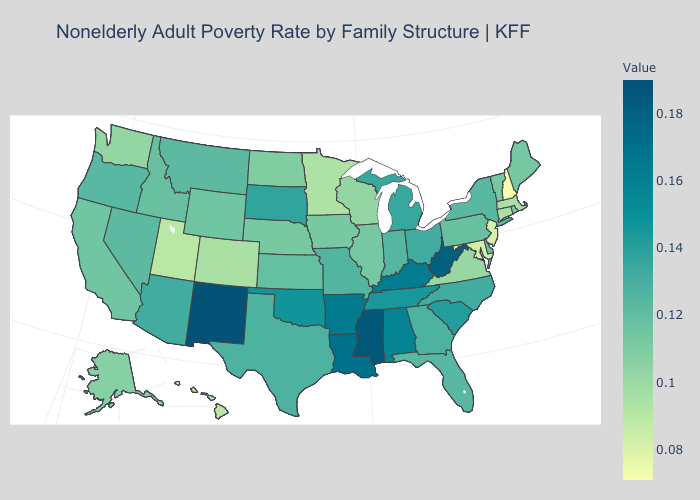Which states have the highest value in the USA?
Be succinct. New Mexico. Does the map have missing data?
Give a very brief answer. No. Which states have the lowest value in the USA?
Answer briefly. New Hampshire. Does Texas have the highest value in the USA?
Be succinct. No. Among the states that border Indiana , which have the lowest value?
Give a very brief answer. Illinois. Does the map have missing data?
Short answer required. No. 